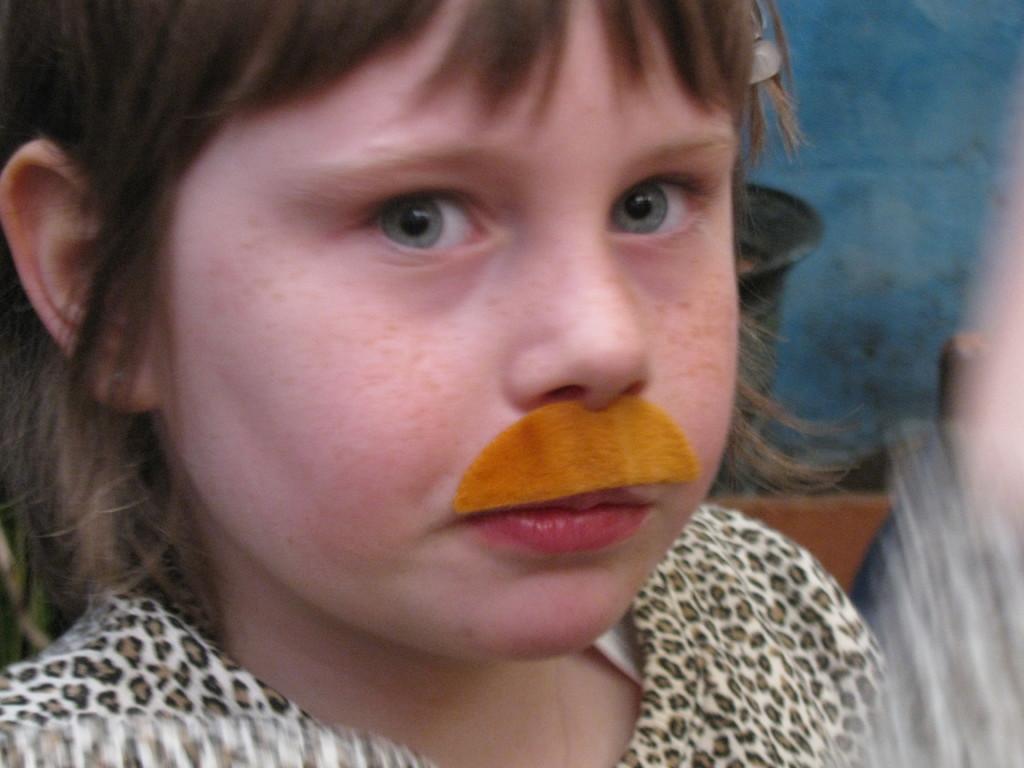Can you describe this image briefly? In this picture I can see there is a child standing here and she is looking at the left and she has some orange mustache and there is a blue color wall in the backdrop. 